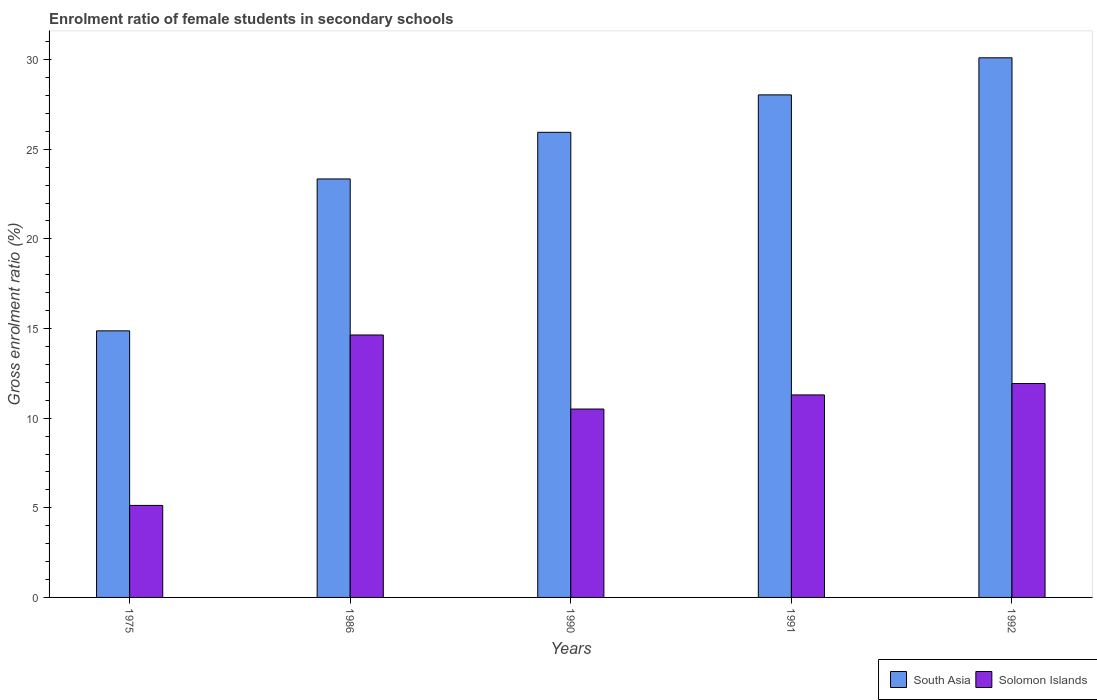How many bars are there on the 4th tick from the right?
Offer a very short reply. 2. What is the label of the 1st group of bars from the left?
Offer a very short reply. 1975. In how many cases, is the number of bars for a given year not equal to the number of legend labels?
Offer a very short reply. 0. What is the enrolment ratio of female students in secondary schools in South Asia in 1991?
Your response must be concise. 28.03. Across all years, what is the maximum enrolment ratio of female students in secondary schools in South Asia?
Your answer should be compact. 30.1. Across all years, what is the minimum enrolment ratio of female students in secondary schools in Solomon Islands?
Offer a terse response. 5.13. In which year was the enrolment ratio of female students in secondary schools in South Asia minimum?
Your answer should be very brief. 1975. What is the total enrolment ratio of female students in secondary schools in Solomon Islands in the graph?
Ensure brevity in your answer.  53.51. What is the difference between the enrolment ratio of female students in secondary schools in South Asia in 1986 and that in 1992?
Offer a very short reply. -6.76. What is the difference between the enrolment ratio of female students in secondary schools in Solomon Islands in 1992 and the enrolment ratio of female students in secondary schools in South Asia in 1991?
Your response must be concise. -16.1. What is the average enrolment ratio of female students in secondary schools in Solomon Islands per year?
Give a very brief answer. 10.7. In the year 1992, what is the difference between the enrolment ratio of female students in secondary schools in South Asia and enrolment ratio of female students in secondary schools in Solomon Islands?
Provide a short and direct response. 18.17. What is the ratio of the enrolment ratio of female students in secondary schools in South Asia in 1990 to that in 1992?
Your answer should be compact. 0.86. Is the difference between the enrolment ratio of female students in secondary schools in South Asia in 1975 and 1986 greater than the difference between the enrolment ratio of female students in secondary schools in Solomon Islands in 1975 and 1986?
Offer a terse response. Yes. What is the difference between the highest and the second highest enrolment ratio of female students in secondary schools in Solomon Islands?
Keep it short and to the point. 2.71. What is the difference between the highest and the lowest enrolment ratio of female students in secondary schools in South Asia?
Provide a succinct answer. 15.23. What does the 2nd bar from the left in 1992 represents?
Offer a very short reply. Solomon Islands. What does the 1st bar from the right in 1986 represents?
Offer a terse response. Solomon Islands. How many bars are there?
Your answer should be compact. 10. What is the difference between two consecutive major ticks on the Y-axis?
Your response must be concise. 5. Where does the legend appear in the graph?
Provide a short and direct response. Bottom right. How many legend labels are there?
Give a very brief answer. 2. What is the title of the graph?
Your answer should be compact. Enrolment ratio of female students in secondary schools. Does "Jamaica" appear as one of the legend labels in the graph?
Ensure brevity in your answer.  No. What is the label or title of the X-axis?
Give a very brief answer. Years. What is the label or title of the Y-axis?
Make the answer very short. Gross enrolment ratio (%). What is the Gross enrolment ratio (%) of South Asia in 1975?
Your answer should be very brief. 14.87. What is the Gross enrolment ratio (%) of Solomon Islands in 1975?
Ensure brevity in your answer.  5.13. What is the Gross enrolment ratio (%) of South Asia in 1986?
Give a very brief answer. 23.34. What is the Gross enrolment ratio (%) in Solomon Islands in 1986?
Your answer should be compact. 14.64. What is the Gross enrolment ratio (%) of South Asia in 1990?
Your answer should be compact. 25.95. What is the Gross enrolment ratio (%) of Solomon Islands in 1990?
Provide a succinct answer. 10.51. What is the Gross enrolment ratio (%) in South Asia in 1991?
Offer a terse response. 28.03. What is the Gross enrolment ratio (%) in Solomon Islands in 1991?
Your answer should be very brief. 11.3. What is the Gross enrolment ratio (%) of South Asia in 1992?
Make the answer very short. 30.1. What is the Gross enrolment ratio (%) in Solomon Islands in 1992?
Offer a very short reply. 11.93. Across all years, what is the maximum Gross enrolment ratio (%) in South Asia?
Offer a very short reply. 30.1. Across all years, what is the maximum Gross enrolment ratio (%) in Solomon Islands?
Provide a succinct answer. 14.64. Across all years, what is the minimum Gross enrolment ratio (%) in South Asia?
Provide a succinct answer. 14.87. Across all years, what is the minimum Gross enrolment ratio (%) of Solomon Islands?
Ensure brevity in your answer.  5.13. What is the total Gross enrolment ratio (%) in South Asia in the graph?
Make the answer very short. 122.3. What is the total Gross enrolment ratio (%) of Solomon Islands in the graph?
Your answer should be very brief. 53.51. What is the difference between the Gross enrolment ratio (%) of South Asia in 1975 and that in 1986?
Ensure brevity in your answer.  -8.47. What is the difference between the Gross enrolment ratio (%) in Solomon Islands in 1975 and that in 1986?
Ensure brevity in your answer.  -9.51. What is the difference between the Gross enrolment ratio (%) of South Asia in 1975 and that in 1990?
Your answer should be compact. -11.07. What is the difference between the Gross enrolment ratio (%) in Solomon Islands in 1975 and that in 1990?
Keep it short and to the point. -5.38. What is the difference between the Gross enrolment ratio (%) of South Asia in 1975 and that in 1991?
Ensure brevity in your answer.  -13.16. What is the difference between the Gross enrolment ratio (%) of Solomon Islands in 1975 and that in 1991?
Your answer should be very brief. -6.16. What is the difference between the Gross enrolment ratio (%) of South Asia in 1975 and that in 1992?
Give a very brief answer. -15.23. What is the difference between the Gross enrolment ratio (%) in Solomon Islands in 1975 and that in 1992?
Offer a very short reply. -6.8. What is the difference between the Gross enrolment ratio (%) of South Asia in 1986 and that in 1990?
Give a very brief answer. -2.6. What is the difference between the Gross enrolment ratio (%) in Solomon Islands in 1986 and that in 1990?
Your answer should be very brief. 4.13. What is the difference between the Gross enrolment ratio (%) of South Asia in 1986 and that in 1991?
Offer a very short reply. -4.69. What is the difference between the Gross enrolment ratio (%) of Solomon Islands in 1986 and that in 1991?
Your answer should be very brief. 3.34. What is the difference between the Gross enrolment ratio (%) of South Asia in 1986 and that in 1992?
Give a very brief answer. -6.76. What is the difference between the Gross enrolment ratio (%) in Solomon Islands in 1986 and that in 1992?
Your answer should be very brief. 2.71. What is the difference between the Gross enrolment ratio (%) of South Asia in 1990 and that in 1991?
Offer a very short reply. -2.09. What is the difference between the Gross enrolment ratio (%) of Solomon Islands in 1990 and that in 1991?
Offer a terse response. -0.79. What is the difference between the Gross enrolment ratio (%) of South Asia in 1990 and that in 1992?
Provide a short and direct response. -4.16. What is the difference between the Gross enrolment ratio (%) in Solomon Islands in 1990 and that in 1992?
Provide a short and direct response. -1.42. What is the difference between the Gross enrolment ratio (%) in South Asia in 1991 and that in 1992?
Your response must be concise. -2.07. What is the difference between the Gross enrolment ratio (%) of Solomon Islands in 1991 and that in 1992?
Make the answer very short. -0.64. What is the difference between the Gross enrolment ratio (%) of South Asia in 1975 and the Gross enrolment ratio (%) of Solomon Islands in 1986?
Give a very brief answer. 0.23. What is the difference between the Gross enrolment ratio (%) of South Asia in 1975 and the Gross enrolment ratio (%) of Solomon Islands in 1990?
Make the answer very short. 4.36. What is the difference between the Gross enrolment ratio (%) in South Asia in 1975 and the Gross enrolment ratio (%) in Solomon Islands in 1991?
Provide a short and direct response. 3.58. What is the difference between the Gross enrolment ratio (%) of South Asia in 1975 and the Gross enrolment ratio (%) of Solomon Islands in 1992?
Provide a short and direct response. 2.94. What is the difference between the Gross enrolment ratio (%) in South Asia in 1986 and the Gross enrolment ratio (%) in Solomon Islands in 1990?
Your answer should be compact. 12.84. What is the difference between the Gross enrolment ratio (%) in South Asia in 1986 and the Gross enrolment ratio (%) in Solomon Islands in 1991?
Give a very brief answer. 12.05. What is the difference between the Gross enrolment ratio (%) in South Asia in 1986 and the Gross enrolment ratio (%) in Solomon Islands in 1992?
Give a very brief answer. 11.41. What is the difference between the Gross enrolment ratio (%) in South Asia in 1990 and the Gross enrolment ratio (%) in Solomon Islands in 1991?
Provide a succinct answer. 14.65. What is the difference between the Gross enrolment ratio (%) in South Asia in 1990 and the Gross enrolment ratio (%) in Solomon Islands in 1992?
Offer a very short reply. 14.01. What is the difference between the Gross enrolment ratio (%) of South Asia in 1991 and the Gross enrolment ratio (%) of Solomon Islands in 1992?
Your response must be concise. 16.1. What is the average Gross enrolment ratio (%) in South Asia per year?
Make the answer very short. 24.46. What is the average Gross enrolment ratio (%) of Solomon Islands per year?
Keep it short and to the point. 10.7. In the year 1975, what is the difference between the Gross enrolment ratio (%) of South Asia and Gross enrolment ratio (%) of Solomon Islands?
Keep it short and to the point. 9.74. In the year 1986, what is the difference between the Gross enrolment ratio (%) of South Asia and Gross enrolment ratio (%) of Solomon Islands?
Provide a succinct answer. 8.7. In the year 1990, what is the difference between the Gross enrolment ratio (%) in South Asia and Gross enrolment ratio (%) in Solomon Islands?
Keep it short and to the point. 15.44. In the year 1991, what is the difference between the Gross enrolment ratio (%) of South Asia and Gross enrolment ratio (%) of Solomon Islands?
Ensure brevity in your answer.  16.74. In the year 1992, what is the difference between the Gross enrolment ratio (%) in South Asia and Gross enrolment ratio (%) in Solomon Islands?
Ensure brevity in your answer.  18.17. What is the ratio of the Gross enrolment ratio (%) of South Asia in 1975 to that in 1986?
Provide a short and direct response. 0.64. What is the ratio of the Gross enrolment ratio (%) of Solomon Islands in 1975 to that in 1986?
Provide a short and direct response. 0.35. What is the ratio of the Gross enrolment ratio (%) of South Asia in 1975 to that in 1990?
Offer a terse response. 0.57. What is the ratio of the Gross enrolment ratio (%) of Solomon Islands in 1975 to that in 1990?
Your response must be concise. 0.49. What is the ratio of the Gross enrolment ratio (%) of South Asia in 1975 to that in 1991?
Ensure brevity in your answer.  0.53. What is the ratio of the Gross enrolment ratio (%) of Solomon Islands in 1975 to that in 1991?
Keep it short and to the point. 0.45. What is the ratio of the Gross enrolment ratio (%) of South Asia in 1975 to that in 1992?
Provide a succinct answer. 0.49. What is the ratio of the Gross enrolment ratio (%) of Solomon Islands in 1975 to that in 1992?
Your answer should be compact. 0.43. What is the ratio of the Gross enrolment ratio (%) in South Asia in 1986 to that in 1990?
Provide a succinct answer. 0.9. What is the ratio of the Gross enrolment ratio (%) in Solomon Islands in 1986 to that in 1990?
Give a very brief answer. 1.39. What is the ratio of the Gross enrolment ratio (%) of South Asia in 1986 to that in 1991?
Your answer should be very brief. 0.83. What is the ratio of the Gross enrolment ratio (%) in Solomon Islands in 1986 to that in 1991?
Keep it short and to the point. 1.3. What is the ratio of the Gross enrolment ratio (%) in South Asia in 1986 to that in 1992?
Your response must be concise. 0.78. What is the ratio of the Gross enrolment ratio (%) in Solomon Islands in 1986 to that in 1992?
Keep it short and to the point. 1.23. What is the ratio of the Gross enrolment ratio (%) in South Asia in 1990 to that in 1991?
Provide a succinct answer. 0.93. What is the ratio of the Gross enrolment ratio (%) of Solomon Islands in 1990 to that in 1991?
Provide a succinct answer. 0.93. What is the ratio of the Gross enrolment ratio (%) of South Asia in 1990 to that in 1992?
Your answer should be compact. 0.86. What is the ratio of the Gross enrolment ratio (%) of Solomon Islands in 1990 to that in 1992?
Your answer should be very brief. 0.88. What is the ratio of the Gross enrolment ratio (%) of South Asia in 1991 to that in 1992?
Provide a succinct answer. 0.93. What is the ratio of the Gross enrolment ratio (%) in Solomon Islands in 1991 to that in 1992?
Offer a very short reply. 0.95. What is the difference between the highest and the second highest Gross enrolment ratio (%) of South Asia?
Offer a terse response. 2.07. What is the difference between the highest and the second highest Gross enrolment ratio (%) in Solomon Islands?
Offer a very short reply. 2.71. What is the difference between the highest and the lowest Gross enrolment ratio (%) of South Asia?
Offer a terse response. 15.23. What is the difference between the highest and the lowest Gross enrolment ratio (%) of Solomon Islands?
Your response must be concise. 9.51. 